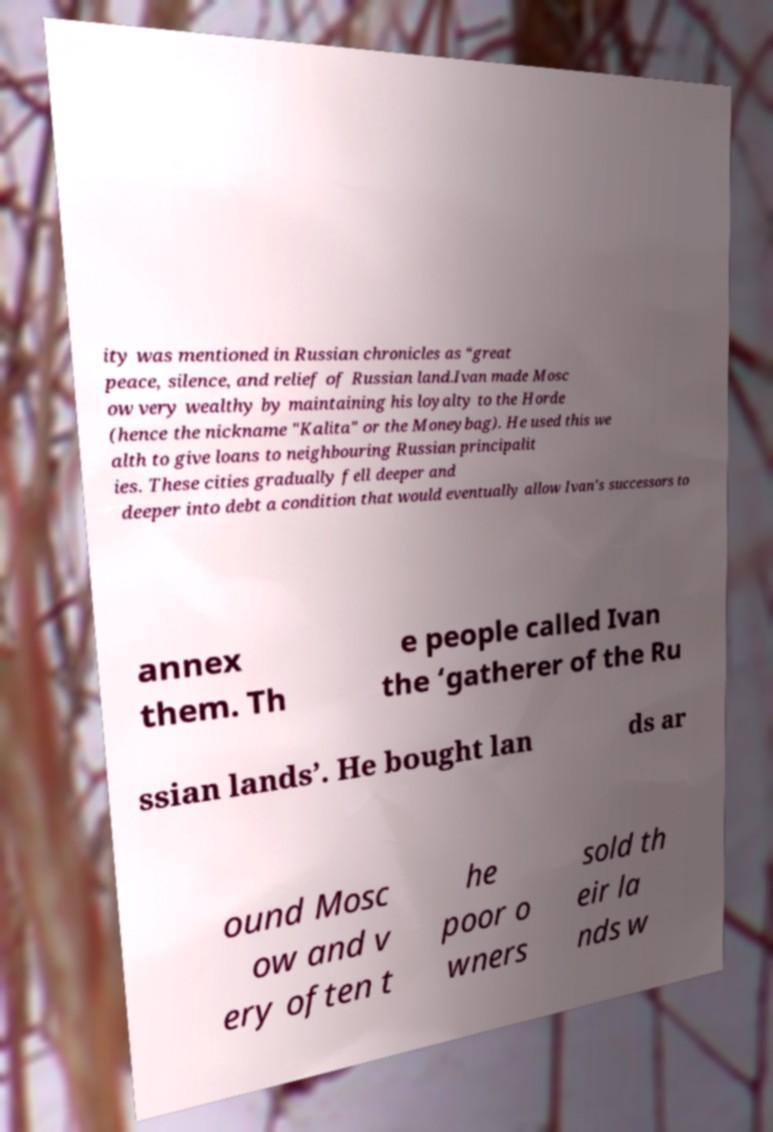For documentation purposes, I need the text within this image transcribed. Could you provide that? ity was mentioned in Russian chronicles as “great peace, silence, and relief of Russian land.Ivan made Mosc ow very wealthy by maintaining his loyalty to the Horde (hence the nickname "Kalita" or the Moneybag). He used this we alth to give loans to neighbouring Russian principalit ies. These cities gradually fell deeper and deeper into debt a condition that would eventually allow Ivan's successors to annex them. Th e people called Ivan the ‘gatherer of the Ru ssian lands’. He bought lan ds ar ound Mosc ow and v ery often t he poor o wners sold th eir la nds w 